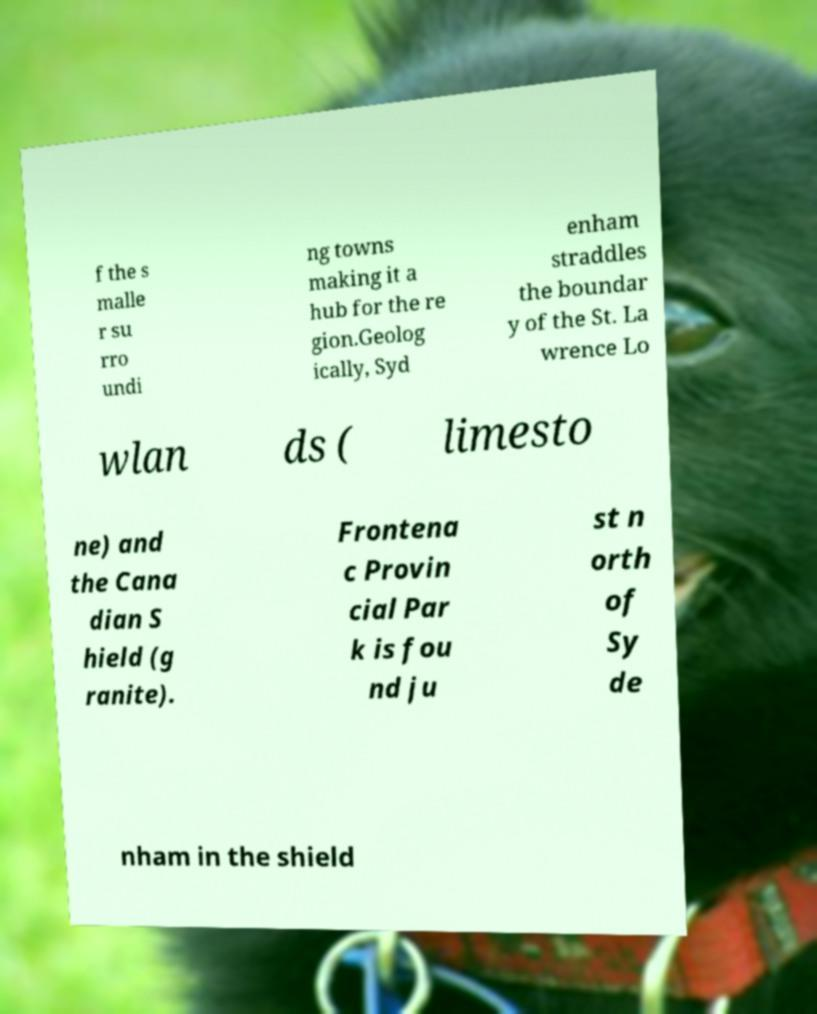Can you accurately transcribe the text from the provided image for me? f the s malle r su rro undi ng towns making it a hub for the re gion.Geolog ically, Syd enham straddles the boundar y of the St. La wrence Lo wlan ds ( limesto ne) and the Cana dian S hield (g ranite). Frontena c Provin cial Par k is fou nd ju st n orth of Sy de nham in the shield 